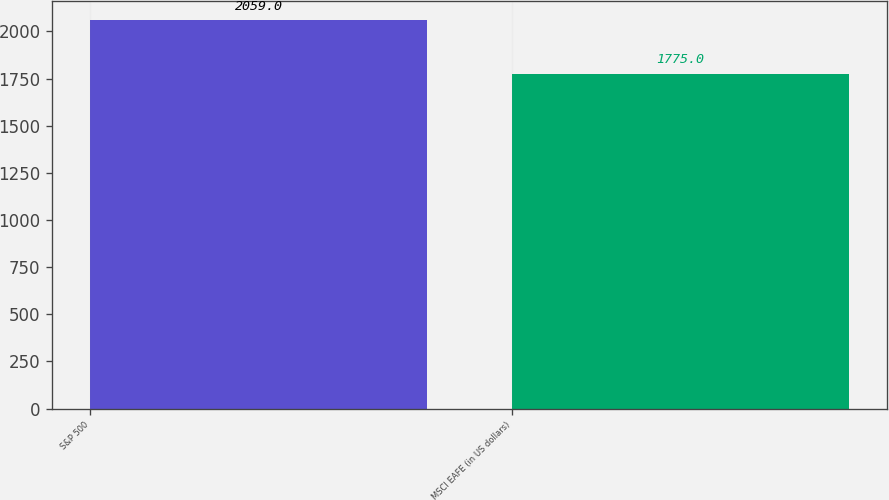<chart> <loc_0><loc_0><loc_500><loc_500><bar_chart><fcel>S&P 500<fcel>MSCI EAFE (in US dollars)<nl><fcel>2059<fcel>1775<nl></chart> 